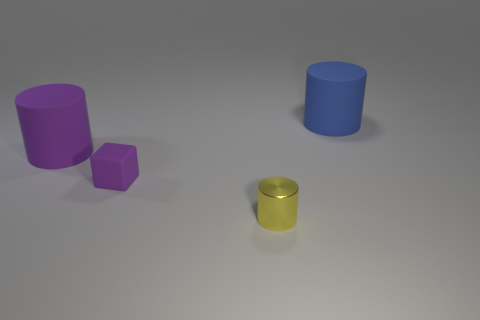Subtract all small yellow metal cylinders. How many cylinders are left? 2 Add 4 purple things. How many objects exist? 8 Subtract all cylinders. How many objects are left? 1 Add 3 blue cylinders. How many blue cylinders are left? 4 Add 1 small yellow cylinders. How many small yellow cylinders exist? 2 Subtract 1 purple cylinders. How many objects are left? 3 Subtract all purple cylinders. Subtract all red cubes. How many cylinders are left? 2 Subtract all big cyan balls. Subtract all tiny yellow cylinders. How many objects are left? 3 